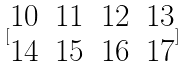Convert formula to latex. <formula><loc_0><loc_0><loc_500><loc_500>[ \begin{matrix} 1 0 & 1 1 & 1 2 & 1 3 \\ 1 4 & 1 5 & 1 6 & 1 7 \end{matrix} ]</formula> 